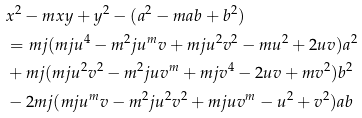<formula> <loc_0><loc_0><loc_500><loc_500>& x ^ { 2 } - m x y + y ^ { 2 } - ( a ^ { 2 } - m a b + b ^ { 2 } ) \\ & = m j ( m j u ^ { 4 } - m ^ { 2 } j u ^ { m } v + m j u ^ { 2 } v ^ { 2 } - m u ^ { 2 } + 2 u v ) a ^ { 2 } \\ & + m j ( m j u ^ { 2 } v ^ { 2 } - m ^ { 2 } j u v ^ { m } + m j v ^ { 4 } - 2 u v + m v ^ { 2 } ) b ^ { 2 } \\ & - 2 m j ( m j u ^ { m } v - m ^ { 2 } j u ^ { 2 } v ^ { 2 } + m j u v ^ { m } - u ^ { 2 } + v ^ { 2 } ) a b</formula> 